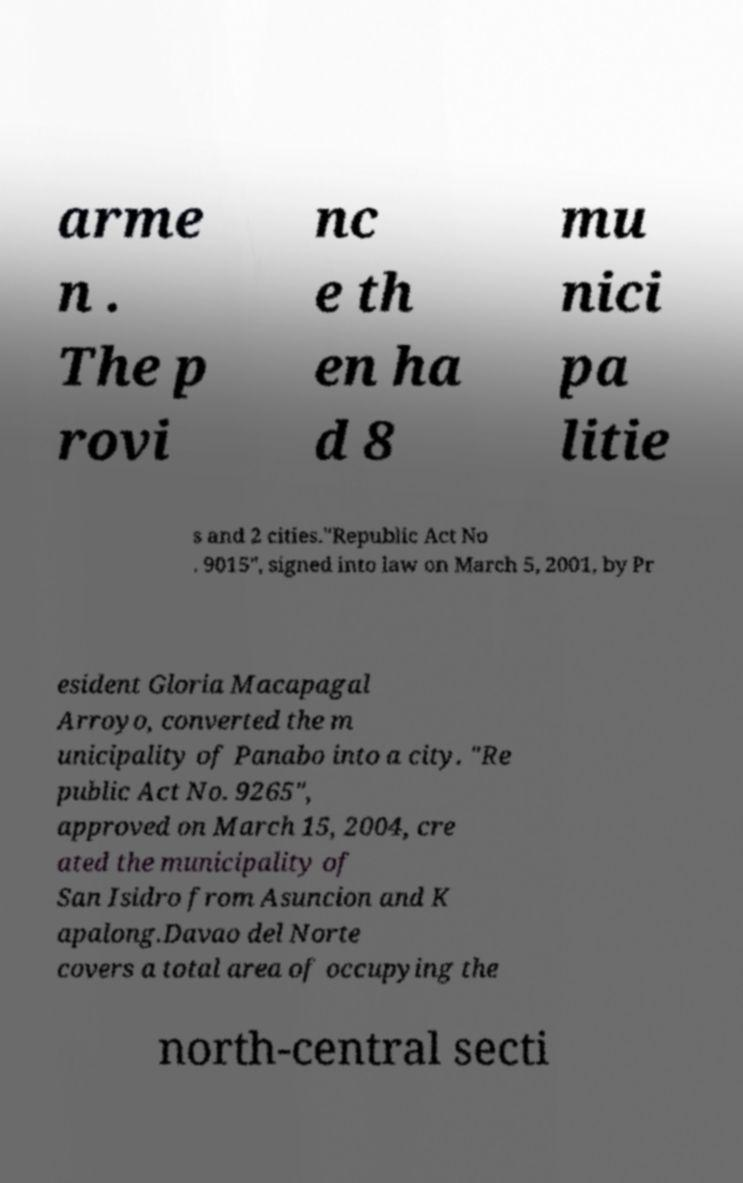Could you assist in decoding the text presented in this image and type it out clearly? arme n . The p rovi nc e th en ha d 8 mu nici pa litie s and 2 cities."Republic Act No . 9015", signed into law on March 5, 2001, by Pr esident Gloria Macapagal Arroyo, converted the m unicipality of Panabo into a city. "Re public Act No. 9265", approved on March 15, 2004, cre ated the municipality of San Isidro from Asuncion and K apalong.Davao del Norte covers a total area of occupying the north-central secti 